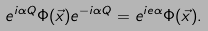<formula> <loc_0><loc_0><loc_500><loc_500>e ^ { i \alpha Q } \Phi ( \vec { x } ) e ^ { - i \alpha Q } = e ^ { i e \alpha } \Phi ( \vec { x } ) .</formula> 